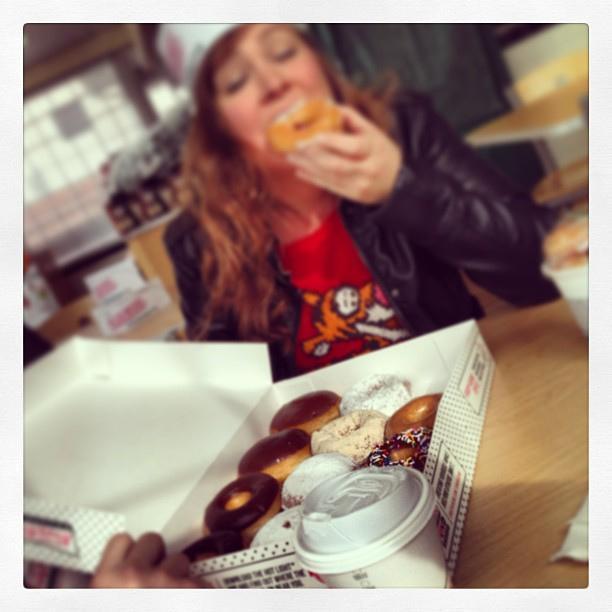How many donuts has the lady eaten?
Give a very brief answer. 1. How many cups are there?
Give a very brief answer. 2. How many donuts are in the picture?
Give a very brief answer. 2. How many people are there?
Give a very brief answer. 2. How many apples are there?
Give a very brief answer. 0. 